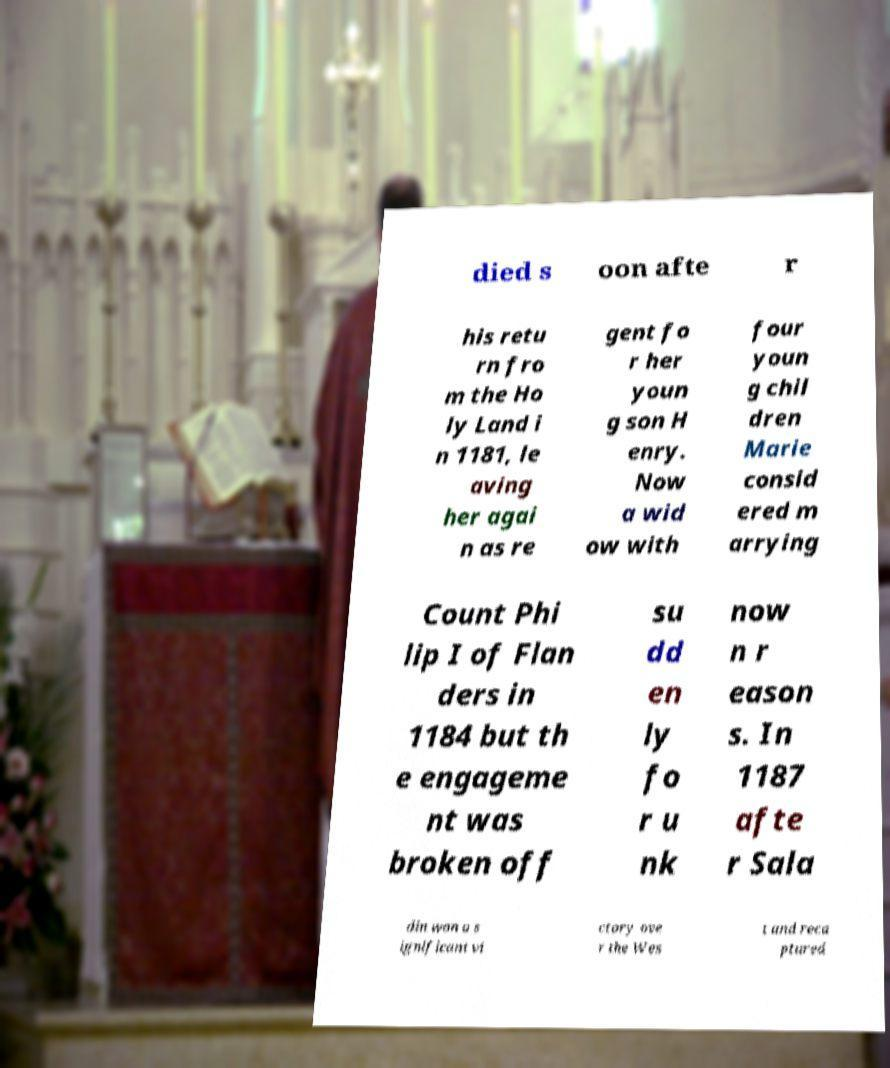Could you extract and type out the text from this image? died s oon afte r his retu rn fro m the Ho ly Land i n 1181, le aving her agai n as re gent fo r her youn g son H enry. Now a wid ow with four youn g chil dren Marie consid ered m arrying Count Phi lip I of Flan ders in 1184 but th e engageme nt was broken off su dd en ly fo r u nk now n r eason s. In 1187 afte r Sala din won a s ignificant vi ctory ove r the Wes t and reca ptured 